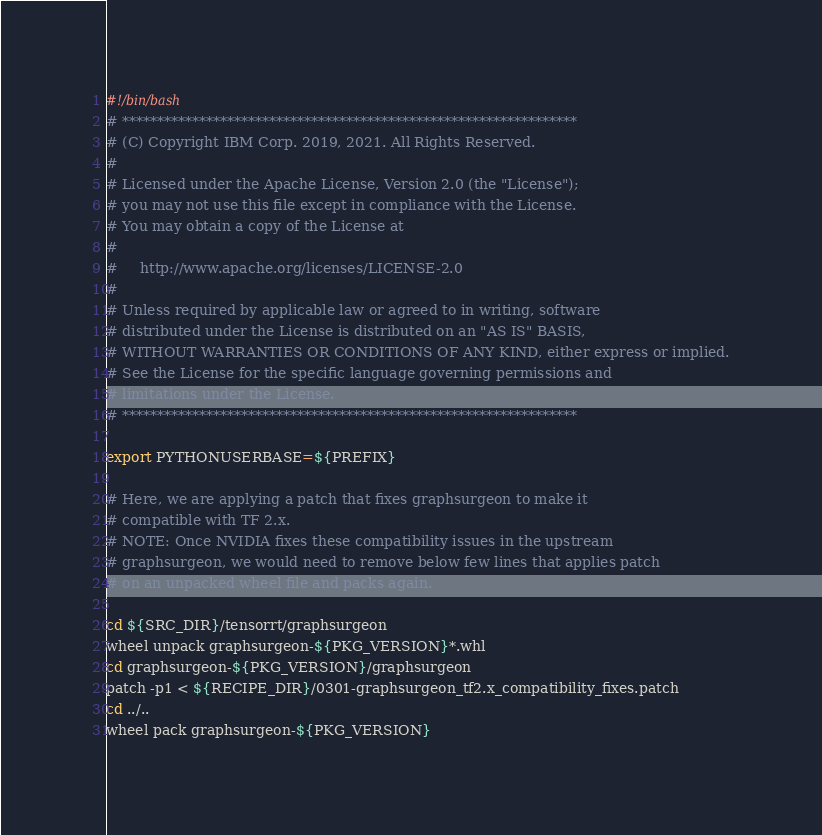Convert code to text. <code><loc_0><loc_0><loc_500><loc_500><_Bash_>#!/bin/bash
# *****************************************************************
# (C) Copyright IBM Corp. 2019, 2021. All Rights Reserved.
#
# Licensed under the Apache License, Version 2.0 (the "License");
# you may not use this file except in compliance with the License.
# You may obtain a copy of the License at
#
#     http://www.apache.org/licenses/LICENSE-2.0
#
# Unless required by applicable law or agreed to in writing, software
# distributed under the License is distributed on an "AS IS" BASIS,
# WITHOUT WARRANTIES OR CONDITIONS OF ANY KIND, either express or implied.
# See the License for the specific language governing permissions and
# limitations under the License.
# *****************************************************************

export PYTHONUSERBASE=${PREFIX}

# Here, we are applying a patch that fixes graphsurgeon to make it 
# compatible with TF 2.x. 
# NOTE: Once NVIDIA fixes these compatibility issues in the upstream 
# graphsurgeon, we would need to remove below few lines that applies patch
# on an unpacked wheel file and packs again.

cd ${SRC_DIR}/tensorrt/graphsurgeon
wheel unpack graphsurgeon-${PKG_VERSION}*.whl
cd graphsurgeon-${PKG_VERSION}/graphsurgeon
patch -p1 < ${RECIPE_DIR}/0301-graphsurgeon_tf2.x_compatibility_fixes.patch
cd ../..
wheel pack graphsurgeon-${PKG_VERSION}
</code> 